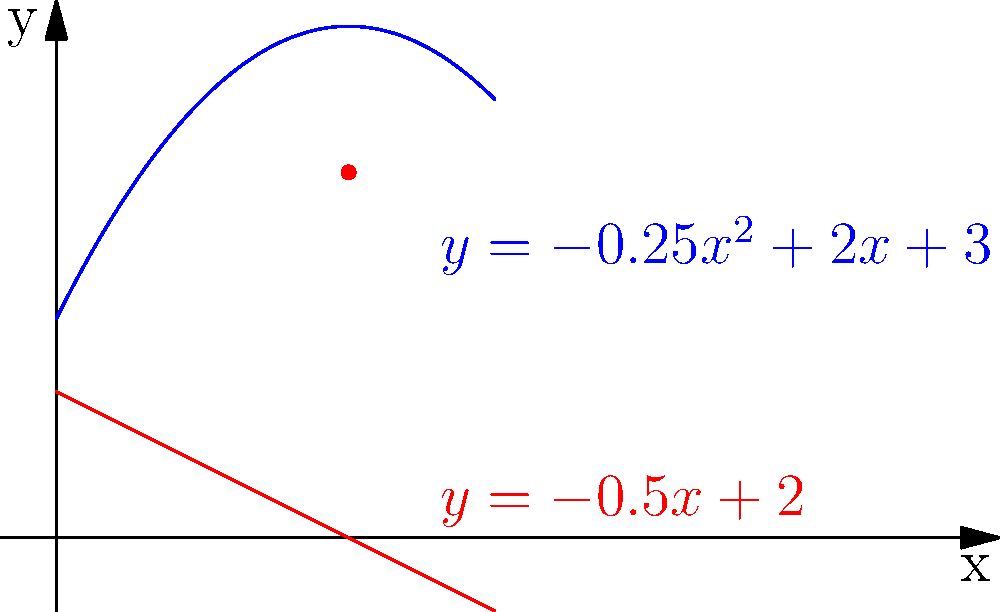During the French Open, a tennis ball's trajectory is modeled by the parabolic function $y = -0.25x^2 + 2x + 3$, where $x$ is the horizontal distance in meters and $y$ is the height in meters. The velocity of the ball is represented by the tangent line to this curve. At what horizontal distance does the ball reach its maximum height, and what is the velocity of the ball at that point? Let's approach this step-by-step:

1) To find the maximum height, we need to find the vertex of the parabola. For a quadratic function $f(x) = ax^2 + bx + c$, the x-coordinate of the vertex is given by $x = -\frac{b}{2a}$.

2) In our case, $a = -0.25$, $b = 2$, and $c = 3$. So:

   $x = -\frac{2}{2(-0.25)} = -\frac{2}{-0.5} = 4$ meters

3) This means the ball reaches its maximum height when $x = 4$ meters.

4) To find the velocity at this point, we need to find the derivative of the function and evaluate it at $x = 4$.

5) The derivative of $y = -0.25x^2 + 2x + 3$ is:
   
   $\frac{dy}{dx} = -0.5x + 2$

6) This represents the slope of the tangent line at any point, which is equivalent to the velocity.

7) At $x = 4$:

   $\frac{dy}{dx} = -0.5(4) + 2 = -2 + 2 = 0$

8) The velocity at the highest point is 0 m/s, which makes sense as the ball momentarily stops rising before it starts falling.

9) The red line in the graph represents the tangent line (and thus the velocity) at the maximum height, which is horizontal, confirming our calculation.
Answer: 4 meters; 0 m/s 